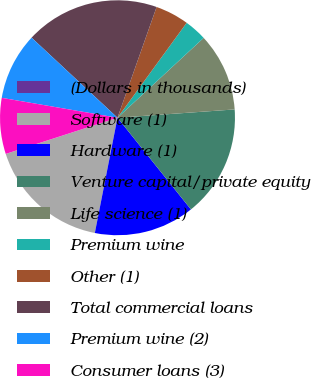<chart> <loc_0><loc_0><loc_500><loc_500><pie_chart><fcel>(Dollars in thousands)<fcel>Software (1)<fcel>Hardware (1)<fcel>Venture capital/private equity<fcel>Life science (1)<fcel>Premium wine<fcel>Other (1)<fcel>Total commercial loans<fcel>Premium wine (2)<fcel>Consumer loans (3)<nl><fcel>0.01%<fcel>16.92%<fcel>13.84%<fcel>15.38%<fcel>10.77%<fcel>3.08%<fcel>4.62%<fcel>18.46%<fcel>9.23%<fcel>7.69%<nl></chart> 